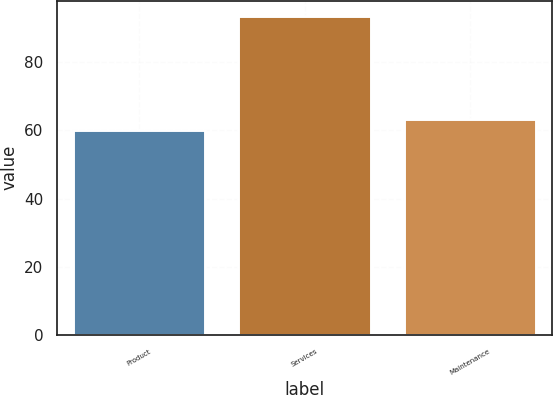Convert chart. <chart><loc_0><loc_0><loc_500><loc_500><bar_chart><fcel>Product<fcel>Services<fcel>Maintenance<nl><fcel>60.1<fcel>93.4<fcel>63.43<nl></chart> 